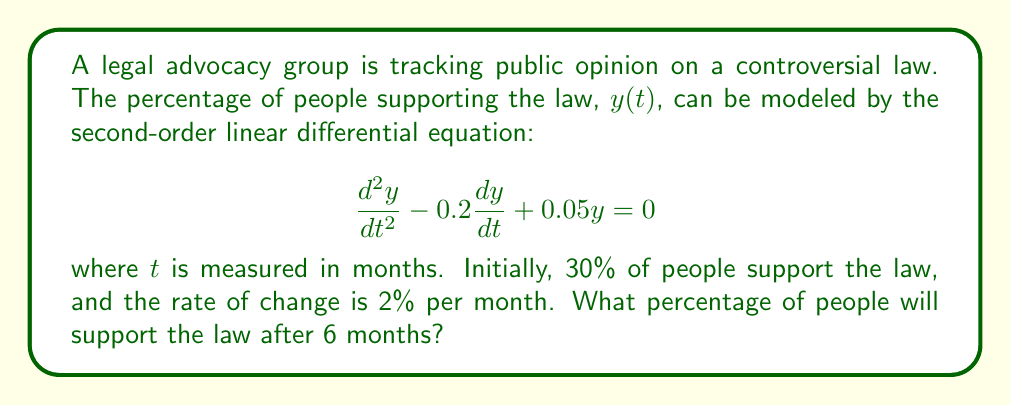Can you answer this question? To solve this problem, we need to follow these steps:

1) First, we need to find the general solution to the differential equation. The characteristic equation is:

   $$r^2 - 0.2r + 0.05 = 0$$

2) Solving this quadratic equation:
   
   $$r = \frac{0.2 \pm \sqrt{0.04 - 0.2}}{2} = \frac{0.2 \pm \sqrt{-0.16}}{2} = 0.1 \pm 0.2i$$

3) Therefore, the general solution is:

   $$y(t) = e^{0.1t}(C_1\cos(0.2t) + C_2\sin(0.2t))$$

4) Now we use the initial conditions to find $C_1$ and $C_2$:

   At $t=0$, $y(0) = 30$, so:
   $$30 = C_1$$

   Also, $y'(t) = 0.1e^{0.1t}(C_1\cos(0.2t) + C_2\sin(0.2t)) + e^{0.1t}(-0.2C_1\sin(0.2t) + 0.2C_2\cos(0.2t))$

   At $t=0$, $y'(0) = 2$, so:
   $$2 = 0.1C_1 + 0.2C_2$$

5) Substituting $C_1 = 30$ into the second equation:

   $$2 = 0.1(30) + 0.2C_2$$
   $$2 = 3 + 0.2C_2$$
   $$-1 = 0.2C_2$$
   $$C_2 = -5$$

6) Now we have the particular solution:

   $$y(t) = e^{0.1t}(30\cos(0.2t) - 5\sin(0.2t))$$

7) To find the percentage after 6 months, we substitute $t=6$:

   $$y(6) = e^{0.6}(30\cos(1.2) - 5\sin(1.2))$$

8) Calculating this (you may use a calculator):

   $$y(6) \approx 44.36$$

Therefore, after 6 months, approximately 44.36% of people will support the law.
Answer: After 6 months, approximately 44.36% of people will support the law. 